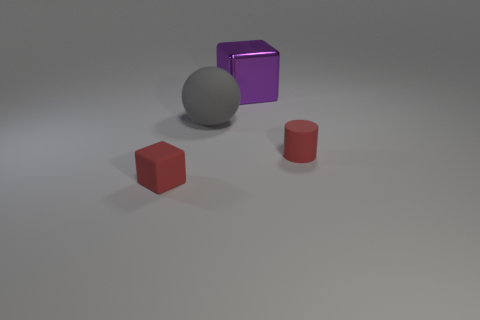Is the color of the small rubber object that is to the right of the tiny red rubber block the same as the tiny matte object that is left of the purple metal thing?
Keep it short and to the point. Yes. There is a thing that is the same size as the red rubber block; what is its material?
Your response must be concise. Rubber. What is the shape of the tiny object left of the red thing that is right of the red thing left of the large metallic thing?
Offer a terse response. Cube. There is a red rubber thing that is the same size as the red cube; what shape is it?
Provide a succinct answer. Cylinder. What number of large shiny blocks are on the left side of the small red object in front of the object that is right of the large block?
Your answer should be very brief. 0. Are there more small objects on the left side of the big metal block than tiny rubber cylinders right of the red rubber cylinder?
Provide a succinct answer. Yes. What number of other gray objects are the same shape as the big shiny object?
Keep it short and to the point. 0. How many things are tiny red rubber objects to the right of the small matte cube or tiny red things that are to the left of the sphere?
Make the answer very short. 2. The red object that is left of the small rubber thing that is behind the tiny red matte thing to the left of the cylinder is made of what material?
Your answer should be compact. Rubber. There is a block that is behind the large rubber ball; is it the same color as the small matte cube?
Keep it short and to the point. No. 